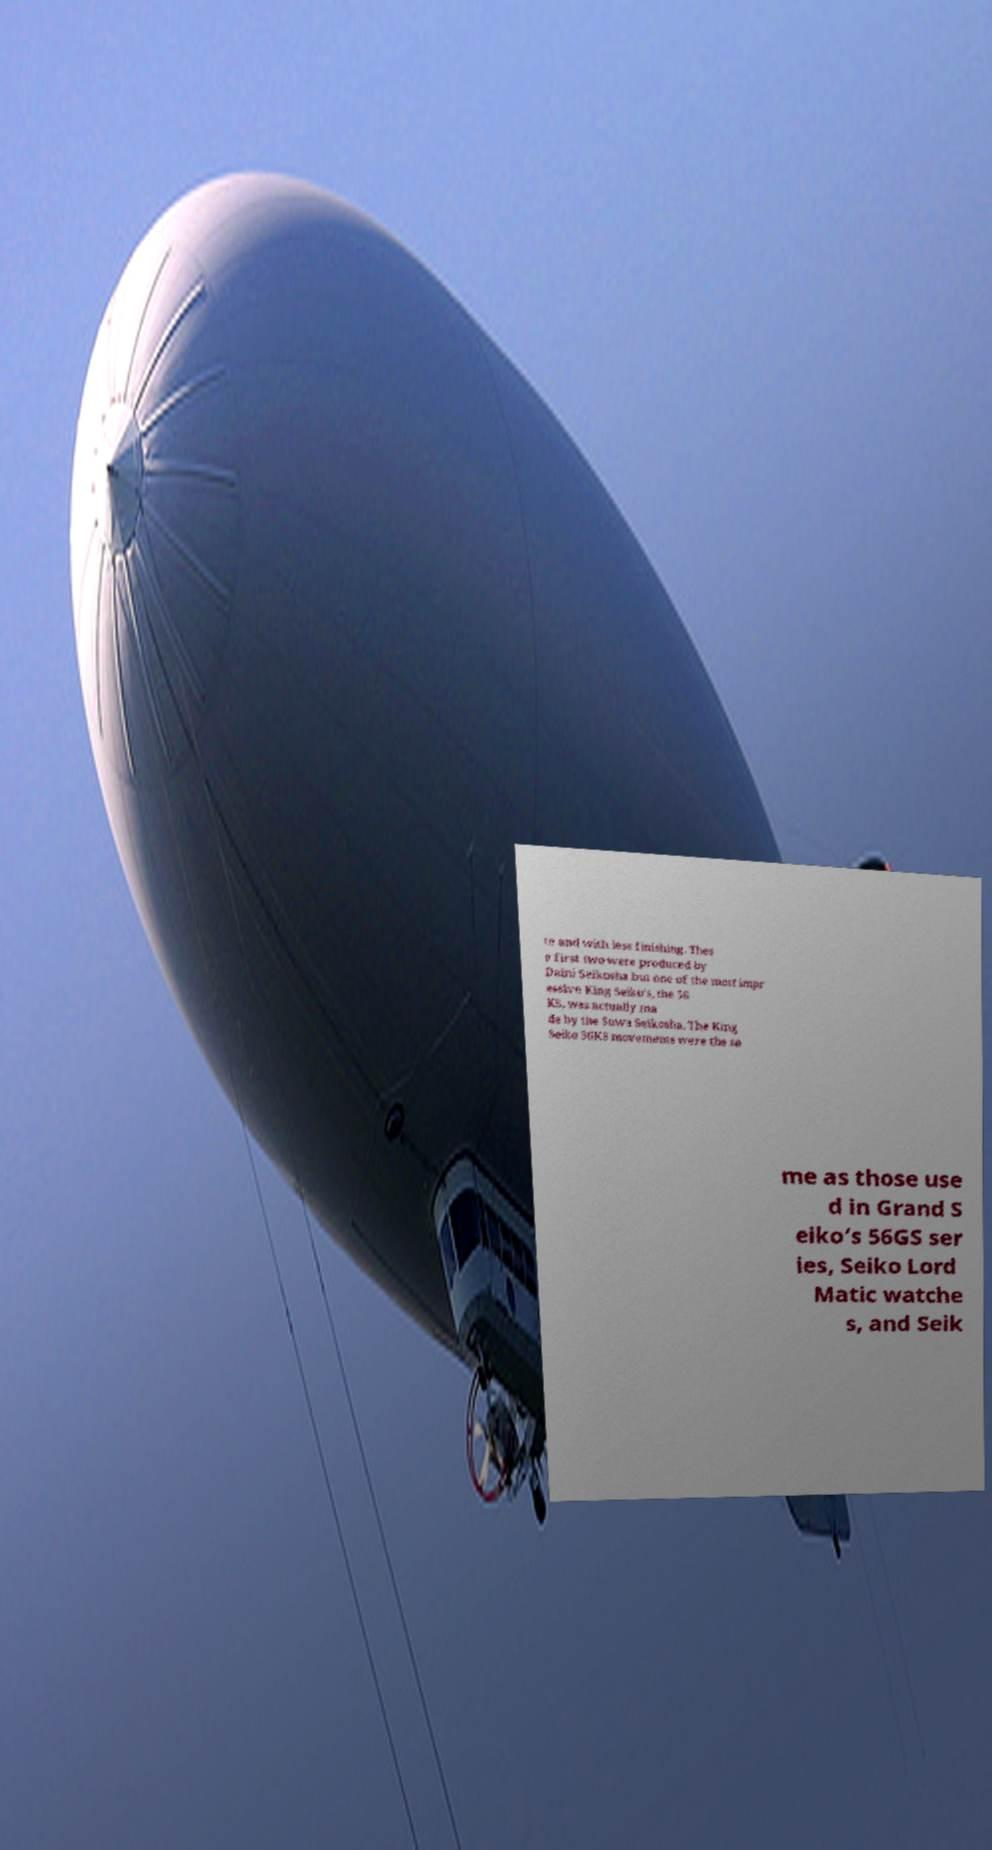Please identify and transcribe the text found in this image. te and with less finishing. Thes e first two were produced by Daini Seikosha but one of the most impr essive King Seiko’s, the 56 KS, was actually ma de by the Suwa Seikosha. The King Seiko 56KS movements were the sa me as those use d in Grand S eiko’s 56GS ser ies, Seiko Lord Matic watche s, and Seik 